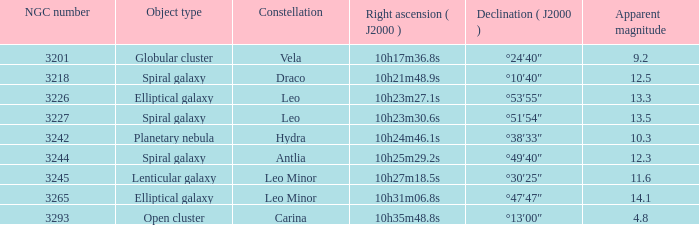What is the sum of NGC numbers for Constellation vela? 3201.0. 